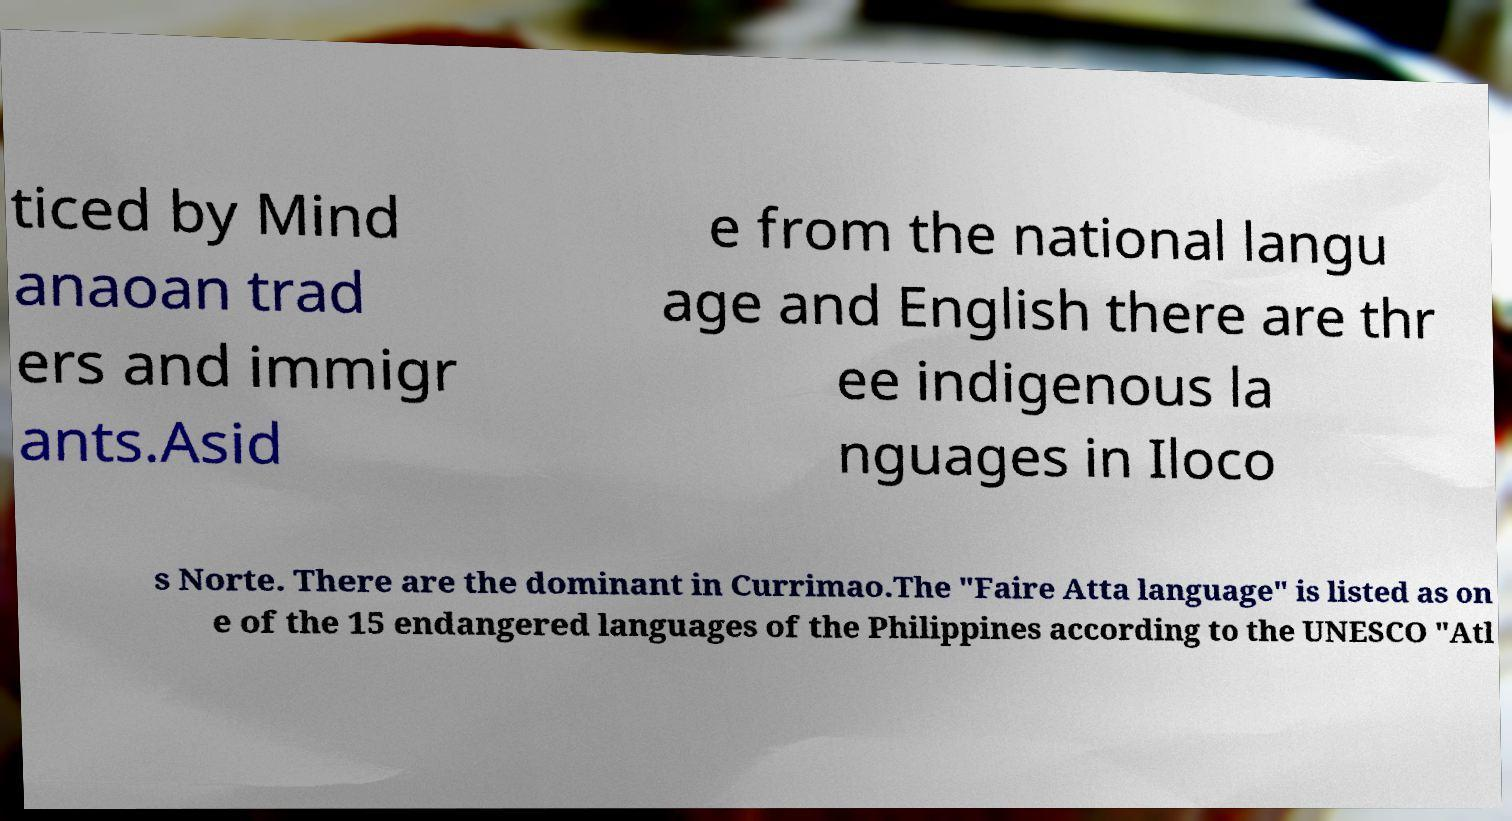I need the written content from this picture converted into text. Can you do that? ticed by Mind anaoan trad ers and immigr ants.Asid e from the national langu age and English there are thr ee indigenous la nguages in Iloco s Norte. There are the dominant in Currimao.The "Faire Atta language" is listed as on e of the 15 endangered languages of the Philippines according to the UNESCO "Atl 